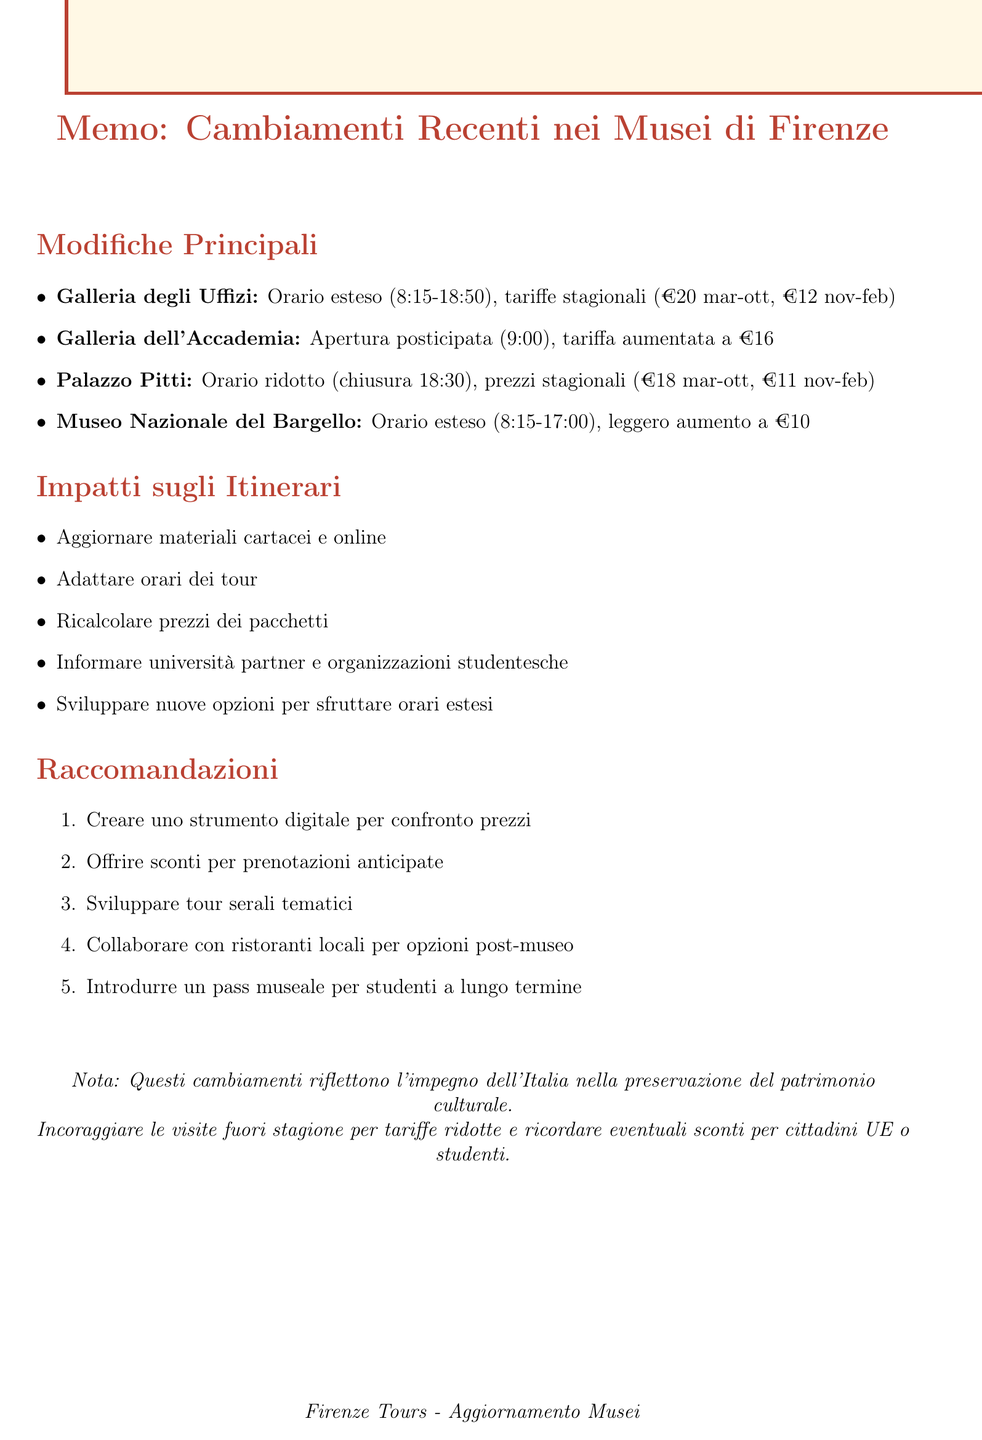What are the new opening hours for the Uffizi Gallery? The new hours for the Uffizi Gallery are Tuesday to Sunday, 8:15 AM to 6:50 PM (closed Mondays).
Answer: Tuesday to Sunday, 8:15 AM to 6:50 PM (closed Mondays) What is the new entrance fee for the Accademia Gallery? The new entrance fee for the Accademia Gallery is €16 (year-round).
Answer: €16 (year-round) How do the changes affect early morning tours at the Accademia Gallery? The later opening time affects early morning tours.
Answer: Affects early morning tours What is the price increase for the Bargello National Museum? The price increase for the Bargello National Museum is from €8 to €10 (year-round).
Answer: From €8 to €10 What general impact do the changes have on tour materials? The general impact is the need to update all printed tour materials and online information.
Answer: Update all printed tour materials and online information What is one of the recommendations mentioned in the document for dealing with price increases? One recommendation is to offer early booking discounts to offset increased fees for budget-conscious students.
Answer: Offer early booking discounts How do the changes at the Uffizi Gallery impact student budgets? The increased high-season prices may affect student budgets.
Answer: May affect student budgets What type of tours is recommended to develop for museums with extended hours? It is recommended to develop themed evening tours for museums with extended hours.
Answer: Themed evening tours What cultural significance is emphasized regarding the new fees? The new fees contribute to the restoration and maintenance of Florence's artistic treasures.
Answer: Restoration and maintenance of Florence's artistic treasures 